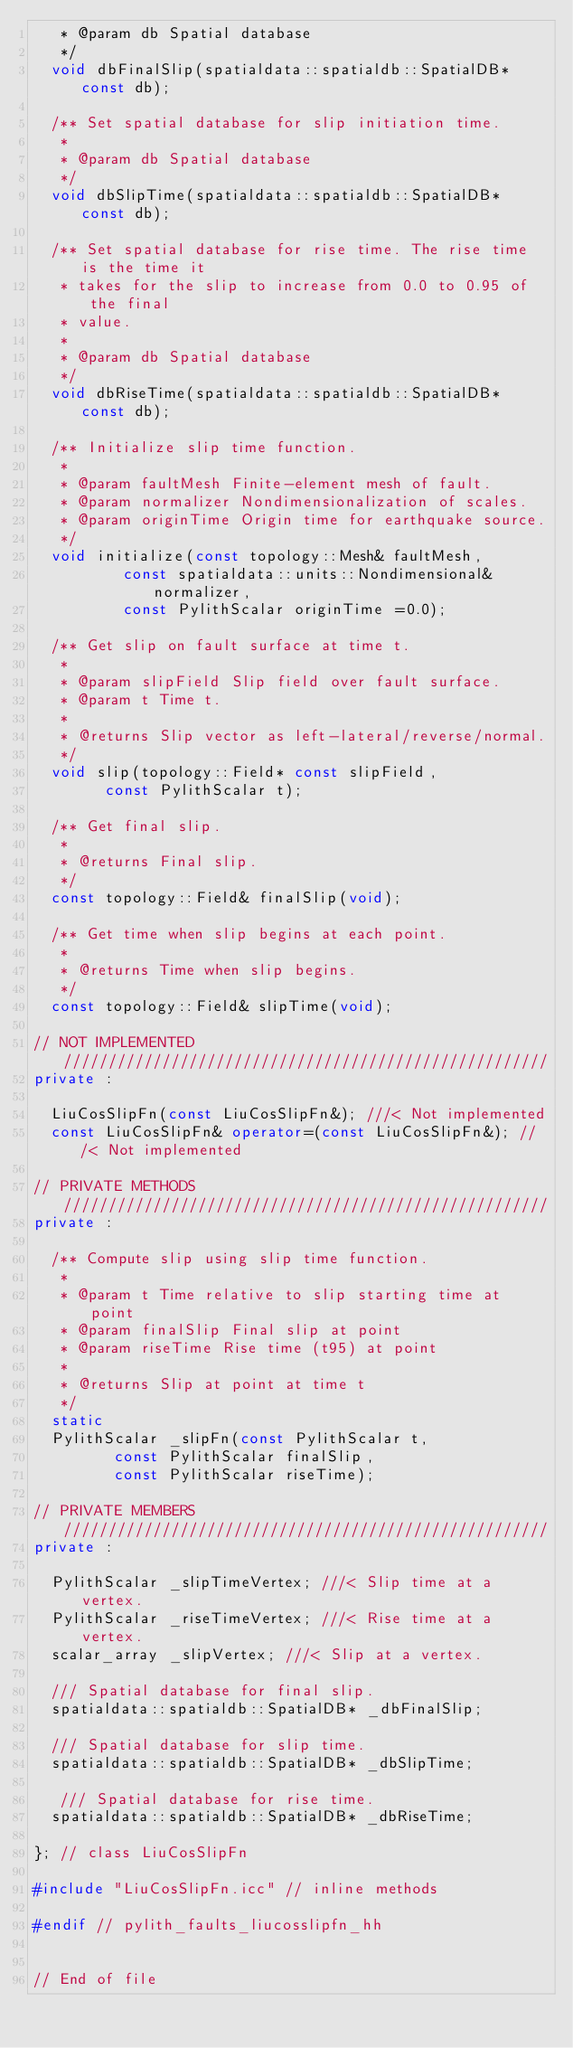Convert code to text. <code><loc_0><loc_0><loc_500><loc_500><_C++_>   * @param db Spatial database
   */
  void dbFinalSlip(spatialdata::spatialdb::SpatialDB* const db);

  /** Set spatial database for slip initiation time.
   *
   * @param db Spatial database
   */
  void dbSlipTime(spatialdata::spatialdb::SpatialDB* const db);

  /** Set spatial database for rise time. The rise time is the time it
   * takes for the slip to increase from 0.0 to 0.95 of the final
   * value.
   *
   * @param db Spatial database
   */
  void dbRiseTime(spatialdata::spatialdb::SpatialDB* const db);

  /** Initialize slip time function.
   *
   * @param faultMesh Finite-element mesh of fault.
   * @param normalizer Nondimensionalization of scales.
   * @param originTime Origin time for earthquake source.
   */
  void initialize(const topology::Mesh& faultMesh,
		  const spatialdata::units::Nondimensional& normalizer,
		  const PylithScalar originTime =0.0);

  /** Get slip on fault surface at time t.
   *
   * @param slipField Slip field over fault surface.
   * @param t Time t.
   *
   * @returns Slip vector as left-lateral/reverse/normal.
   */
  void slip(topology::Field* const slipField,
	    const PylithScalar t);
  
  /** Get final slip.
   *
   * @returns Final slip.
   */
  const topology::Field& finalSlip(void);

  /** Get time when slip begins at each point.
   *
   * @returns Time when slip begins.
   */
  const topology::Field& slipTime(void);

// NOT IMPLEMENTED //////////////////////////////////////////////////////
private :

  LiuCosSlipFn(const LiuCosSlipFn&); ///< Not implemented
  const LiuCosSlipFn& operator=(const LiuCosSlipFn&); ///< Not implemented

// PRIVATE METHODS //////////////////////////////////////////////////////
private :

  /** Compute slip using slip time function.
   *
   * @param t Time relative to slip starting time at point
   * @param finalSlip Final slip at point
   * @param riseTime Rise time (t95) at point
   *
   * @returns Slip at point at time t
   */
  static
  PylithScalar _slipFn(const PylithScalar t,
		 const PylithScalar finalSlip,
		 const PylithScalar riseTime);

// PRIVATE MEMBERS //////////////////////////////////////////////////////
private :

  PylithScalar _slipTimeVertex; ///< Slip time at a vertex.
  PylithScalar _riseTimeVertex; ///< Rise time at a vertex.
  scalar_array _slipVertex; ///< Slip at a vertex.

  /// Spatial database for final slip.
  spatialdata::spatialdb::SpatialDB* _dbFinalSlip;

  /// Spatial database for slip time.
  spatialdata::spatialdb::SpatialDB* _dbSlipTime;

   /// Spatial database for rise time.
  spatialdata::spatialdb::SpatialDB* _dbRiseTime;

}; // class LiuCosSlipFn

#include "LiuCosSlipFn.icc" // inline methods

#endif // pylith_faults_liucosslipfn_hh


// End of file 
</code> 